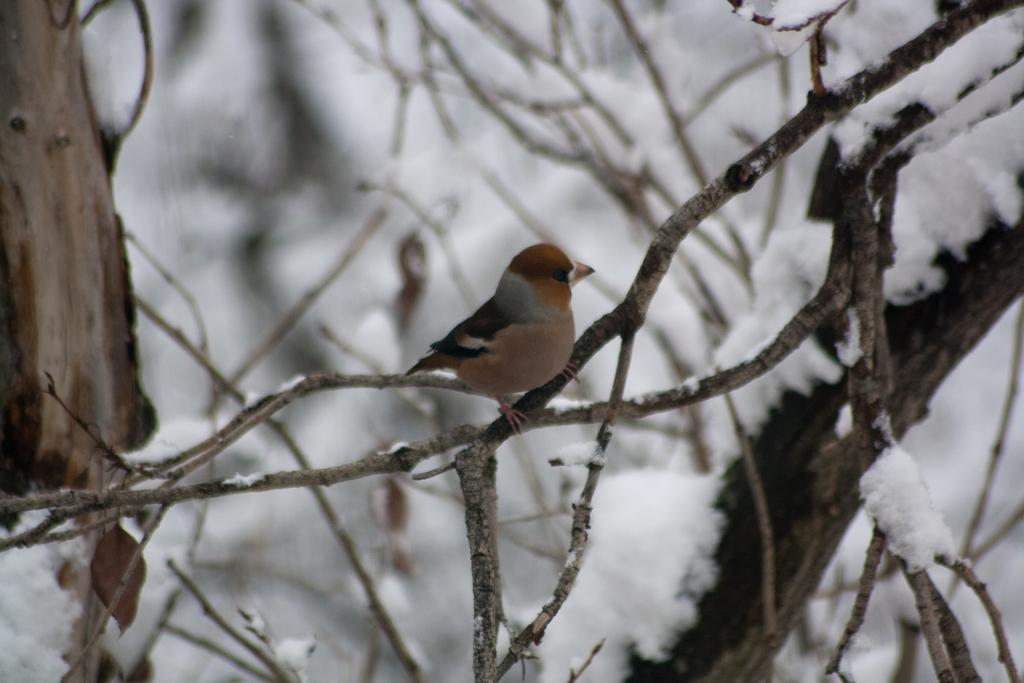What type of animal is in the image? There is a bird in the image. Where is the bird located in the image? The bird is standing on a branch. What is the branch attached to in the image? The branch is from a tree. What is the position of the tree in the image? The tree is in the center of the image. What type of juice is being squeezed from the wool in the image? There is no juice or wool present in the image; it features a bird standing on a branch from a tree. 